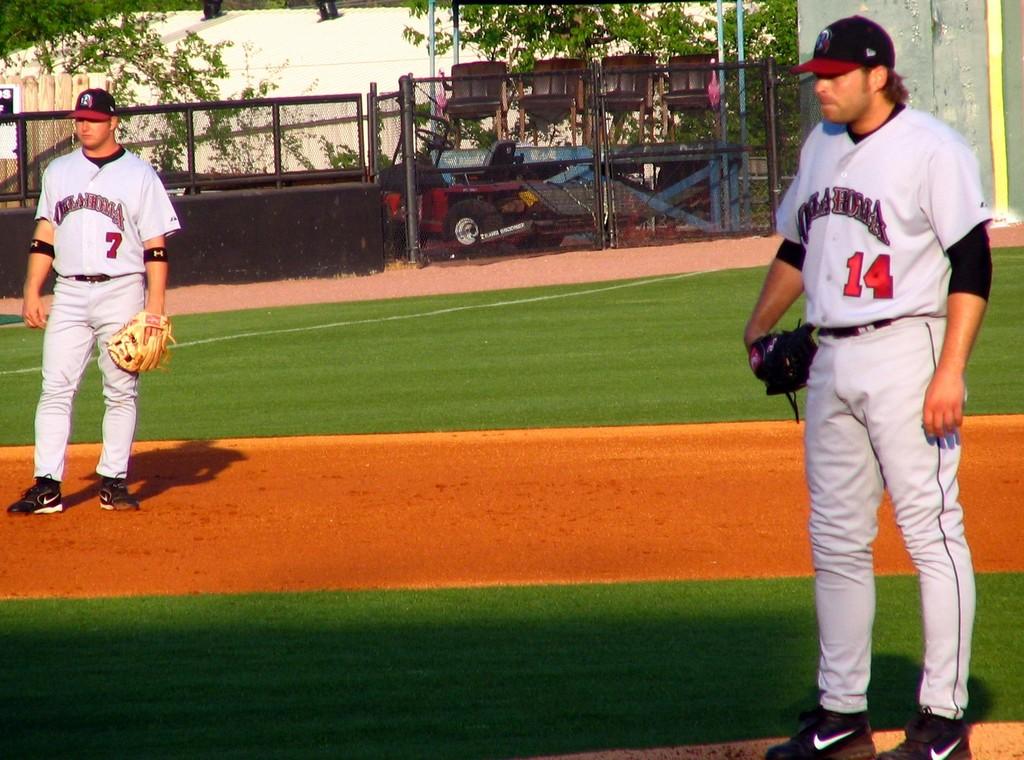What number is on the jersey to the right?
Provide a short and direct response. 14. 